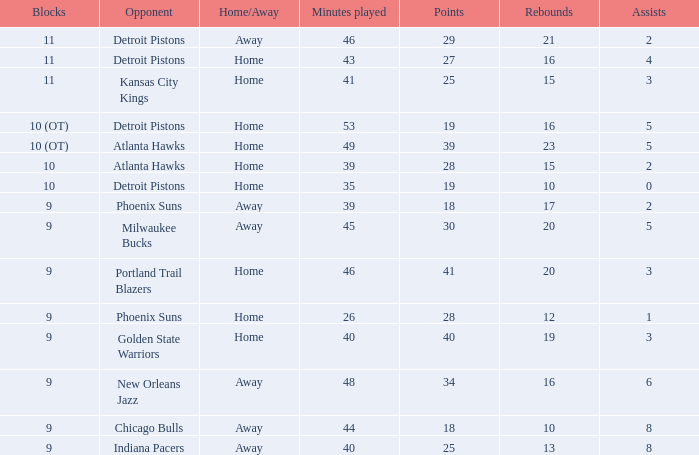How many points were there when there were less than 16 rebounds and 5 assists? 0.0. Give me the full table as a dictionary. {'header': ['Blocks', 'Opponent', 'Home/Away', 'Minutes played', 'Points', 'Rebounds', 'Assists'], 'rows': [['11', 'Detroit Pistons', 'Away', '46', '29', '21', '2'], ['11', 'Detroit Pistons', 'Home', '43', '27', '16', '4'], ['11', 'Kansas City Kings', 'Home', '41', '25', '15', '3'], ['10 (OT)', 'Detroit Pistons', 'Home', '53', '19', '16', '5'], ['10 (OT)', 'Atlanta Hawks', 'Home', '49', '39', '23', '5'], ['10', 'Atlanta Hawks', 'Home', '39', '28', '15', '2'], ['10', 'Detroit Pistons', 'Home', '35', '19', '10', '0'], ['9', 'Phoenix Suns', 'Away', '39', '18', '17', '2'], ['9', 'Milwaukee Bucks', 'Away', '45', '30', '20', '5'], ['9', 'Portland Trail Blazers', 'Home', '46', '41', '20', '3'], ['9', 'Phoenix Suns', 'Home', '26', '28', '12', '1'], ['9', 'Golden State Warriors', 'Home', '40', '40', '19', '3'], ['9', 'New Orleans Jazz', 'Away', '48', '34', '16', '6'], ['9', 'Chicago Bulls', 'Away', '44', '18', '10', '8'], ['9', 'Indiana Pacers', 'Away', '40', '25', '13', '8']]} 